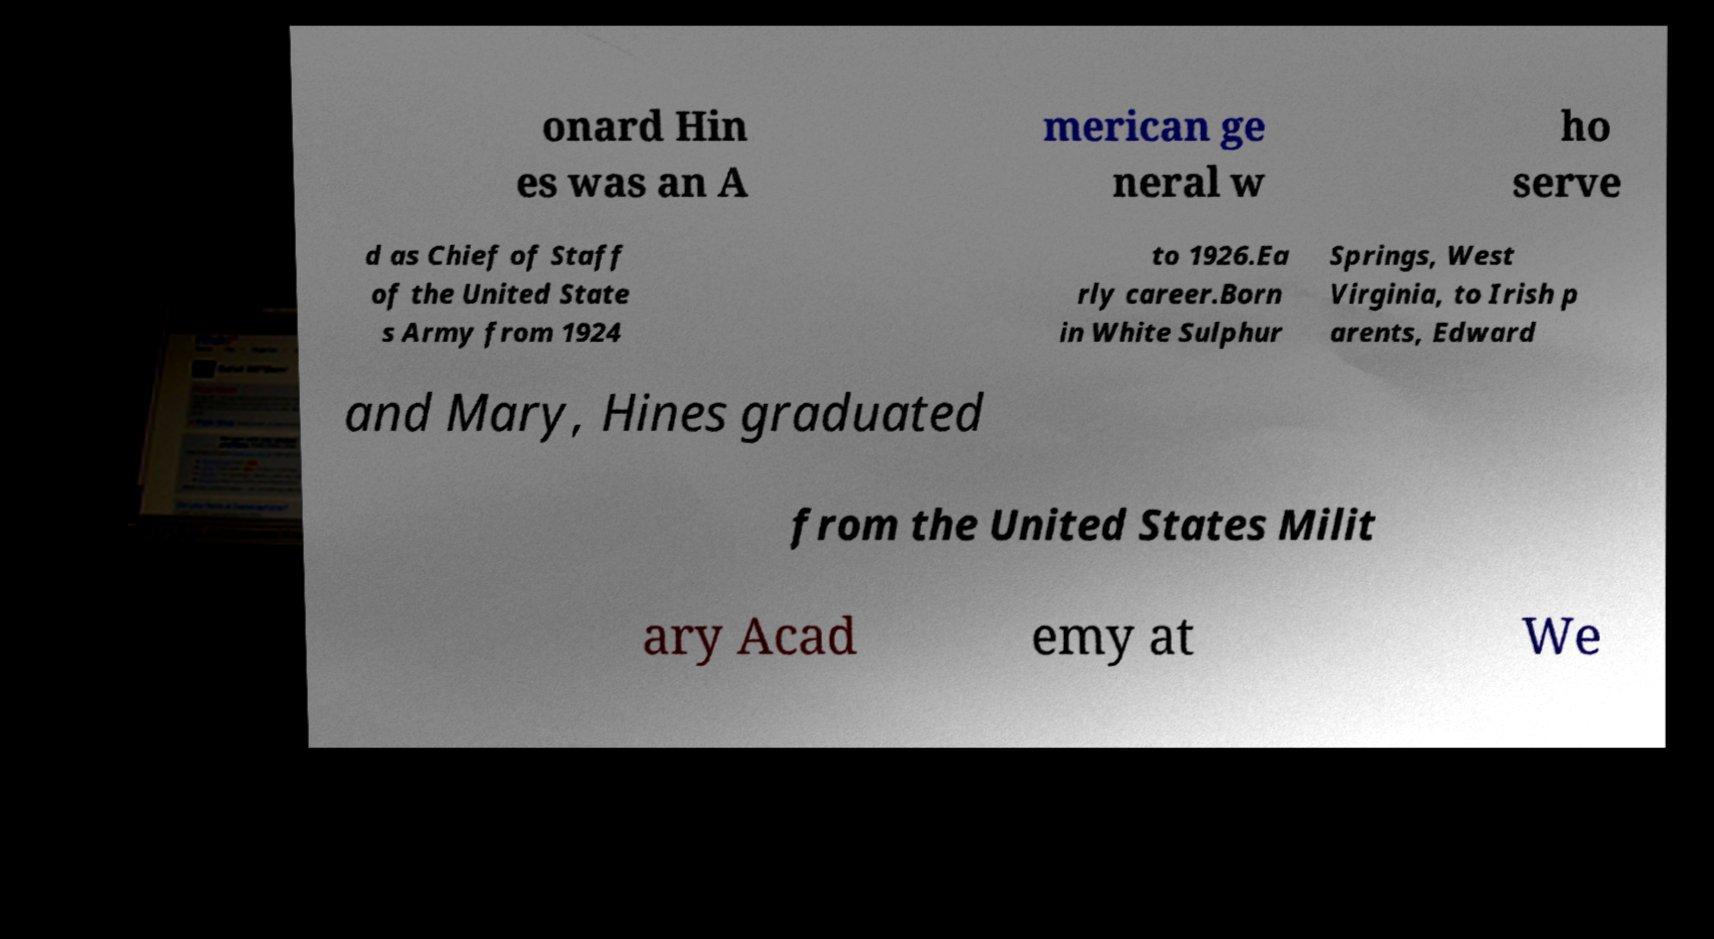Please read and relay the text visible in this image. What does it say? onard Hin es was an A merican ge neral w ho serve d as Chief of Staff of the United State s Army from 1924 to 1926.Ea rly career.Born in White Sulphur Springs, West Virginia, to Irish p arents, Edward and Mary, Hines graduated from the United States Milit ary Acad emy at We 